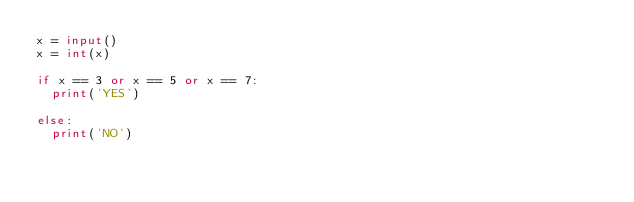Convert code to text. <code><loc_0><loc_0><loc_500><loc_500><_Python_>x = input()
x = int(x)

if x == 3 or x == 5 or x == 7: 
  print('YES')

else:
  print('NO')
  </code> 